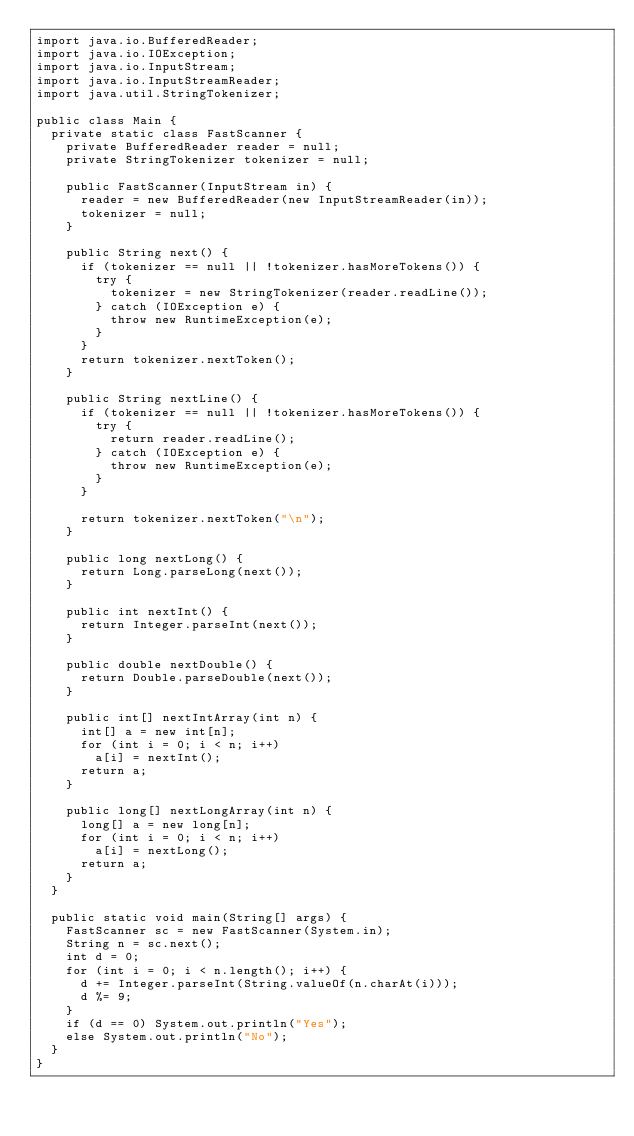<code> <loc_0><loc_0><loc_500><loc_500><_Java_>import java.io.BufferedReader;
import java.io.IOException;
import java.io.InputStream;
import java.io.InputStreamReader;
import java.util.StringTokenizer;

public class Main {
  private static class FastScanner {
    private BufferedReader reader = null;
    private StringTokenizer tokenizer = null;

    public FastScanner(InputStream in) {
      reader = new BufferedReader(new InputStreamReader(in));
      tokenizer = null;
    }

    public String next() {
      if (tokenizer == null || !tokenizer.hasMoreTokens()) {
        try {
          tokenizer = new StringTokenizer(reader.readLine());
        } catch (IOException e) {
          throw new RuntimeException(e);
        }
      }
      return tokenizer.nextToken();
    }

    public String nextLine() {
      if (tokenizer == null || !tokenizer.hasMoreTokens()) {
        try {
          return reader.readLine();
        } catch (IOException e) {
          throw new RuntimeException(e);
        }
      }

      return tokenizer.nextToken("\n");
    }

    public long nextLong() {
      return Long.parseLong(next());
    }

    public int nextInt() {
      return Integer.parseInt(next());
    }

    public double nextDouble() {
      return Double.parseDouble(next());
    }

    public int[] nextIntArray(int n) {
      int[] a = new int[n];
      for (int i = 0; i < n; i++)
        a[i] = nextInt();
      return a;
    }

    public long[] nextLongArray(int n) {
      long[] a = new long[n];
      for (int i = 0; i < n; i++)
        a[i] = nextLong();
      return a;
    }
  }

  public static void main(String[] args) {
    FastScanner sc = new FastScanner(System.in);
    String n = sc.next();
    int d = 0;
    for (int i = 0; i < n.length(); i++) {
      d += Integer.parseInt(String.valueOf(n.charAt(i)));
      d %= 9;
    }
    if (d == 0) System.out.println("Yes");
    else System.out.println("No");
  }
}</code> 